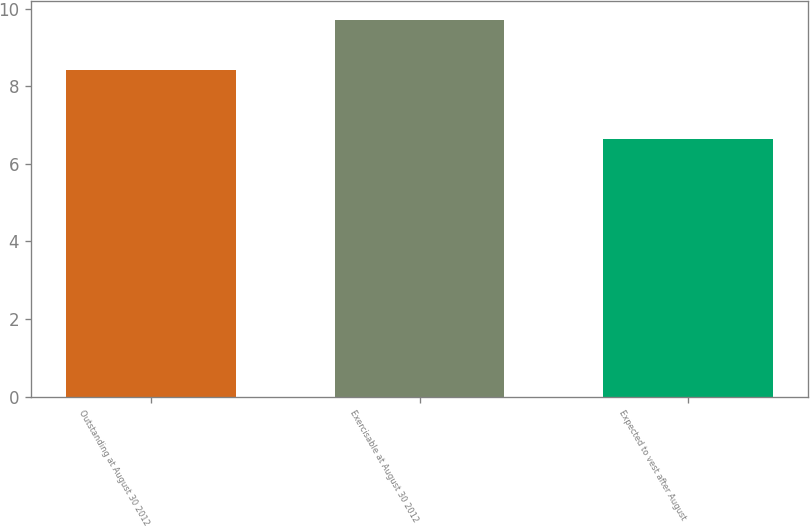Convert chart to OTSL. <chart><loc_0><loc_0><loc_500><loc_500><bar_chart><fcel>Outstanding at August 30 2012<fcel>Exercisable at August 30 2012<fcel>Expected to vest after August<nl><fcel>8.42<fcel>9.71<fcel>6.65<nl></chart> 